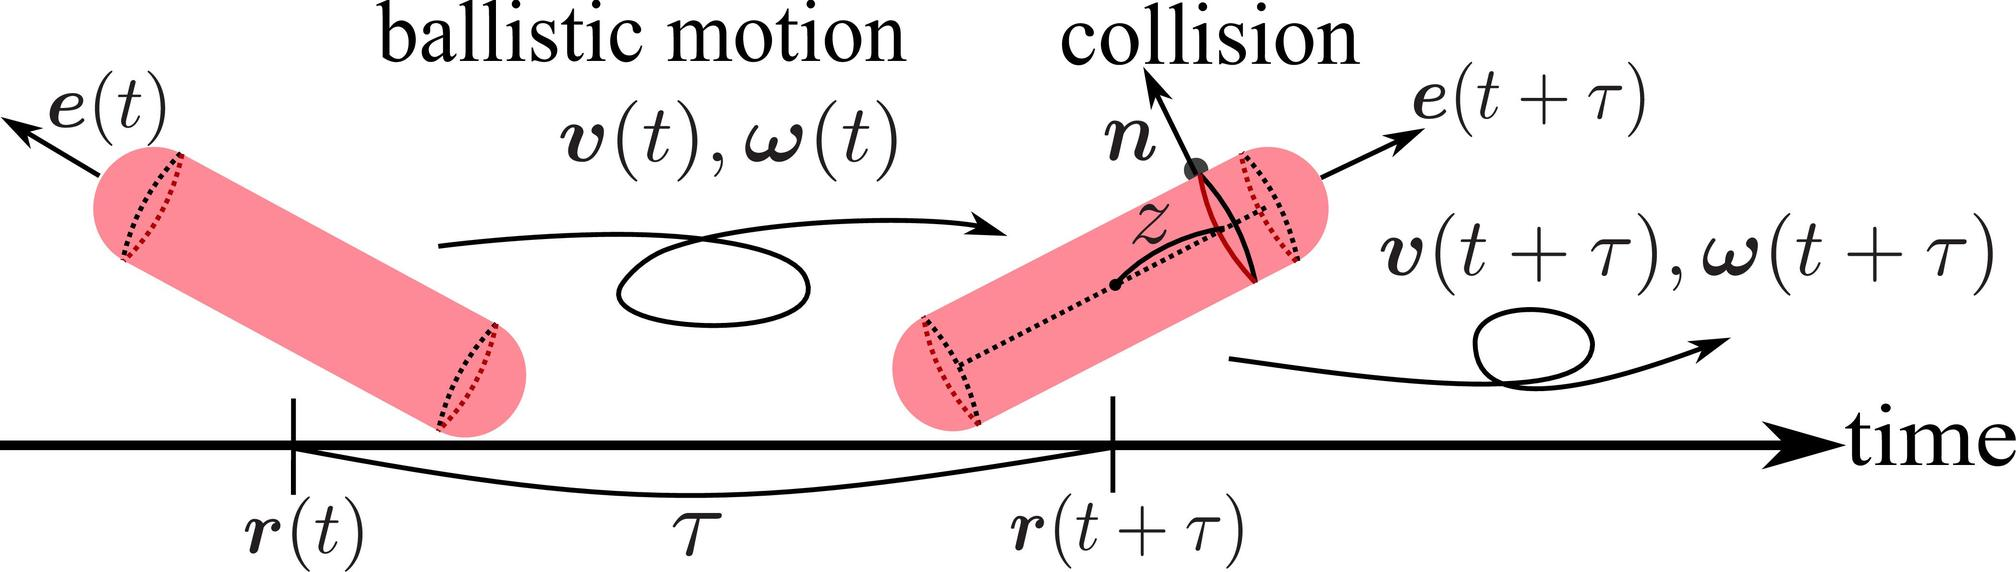How does the normal vector 'n' affect the collision outcome illustrated in the diagram? The normal vector 'n' in the diagram is perpendicular to the point of contact at the moment of collision. It's critical because it dictates the direction in which force is applied to the cylinder, influencing how the cylinder's orientation and velocity change. Essentially, 'n' determines the angle of deflection of the cylinder post-collision, thereby influencing the new trajectory and rotational changes according to Newton’s laws of motion and the principles of conservation of momentum. 